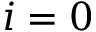<formula> <loc_0><loc_0><loc_500><loc_500>i = 0</formula> 